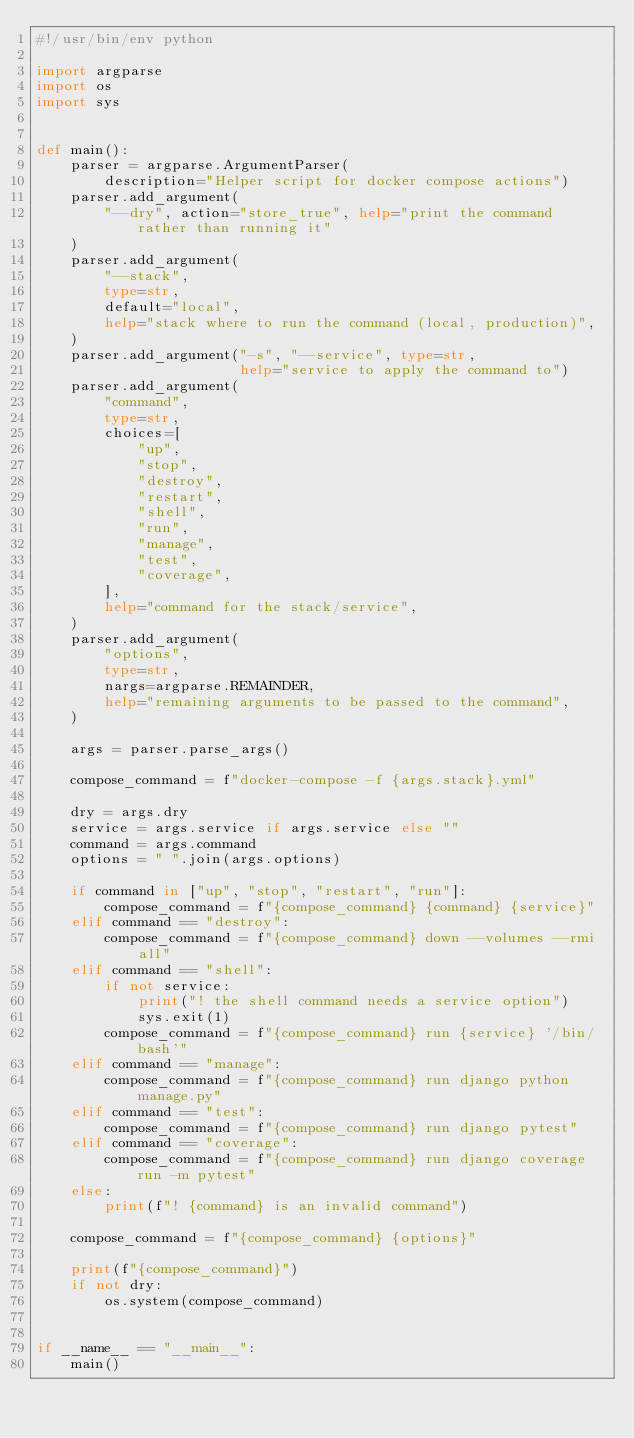<code> <loc_0><loc_0><loc_500><loc_500><_Python_>#!/usr/bin/env python

import argparse
import os
import sys


def main():
    parser = argparse.ArgumentParser(
        description="Helper script for docker compose actions")
    parser.add_argument(
        "--dry", action="store_true", help="print the command rather than running it"
    )
    parser.add_argument(
        "--stack",
        type=str,
        default="local",
        help="stack where to run the command (local, production)",
    )
    parser.add_argument("-s", "--service", type=str,
                        help="service to apply the command to")
    parser.add_argument(
        "command",
        type=str,
        choices=[
            "up",
            "stop",
            "destroy",
            "restart",
            "shell",
            "run",
            "manage",
            "test",
            "coverage",
        ],
        help="command for the stack/service",
    )
    parser.add_argument(
        "options",
        type=str,
        nargs=argparse.REMAINDER,
        help="remaining arguments to be passed to the command",
    )

    args = parser.parse_args()

    compose_command = f"docker-compose -f {args.stack}.yml"

    dry = args.dry
    service = args.service if args.service else ""
    command = args.command
    options = " ".join(args.options)

    if command in ["up", "stop", "restart", "run"]:
        compose_command = f"{compose_command} {command} {service}"
    elif command == "destroy":
        compose_command = f"{compose_command} down --volumes --rmi all"
    elif command == "shell":
        if not service:
            print("! the shell command needs a service option")
            sys.exit(1)
        compose_command = f"{compose_command} run {service} '/bin/bash'"
    elif command == "manage":
        compose_command = f"{compose_command} run django python manage.py"
    elif command == "test":
        compose_command = f"{compose_command} run django pytest"
    elif command == "coverage":
        compose_command = f"{compose_command} run django coverage run -m pytest"
    else:
        print(f"! {command} is an invalid command")

    compose_command = f"{compose_command} {options}"

    print(f"{compose_command}")
    if not dry:
        os.system(compose_command)


if __name__ == "__main__":
    main()
</code> 